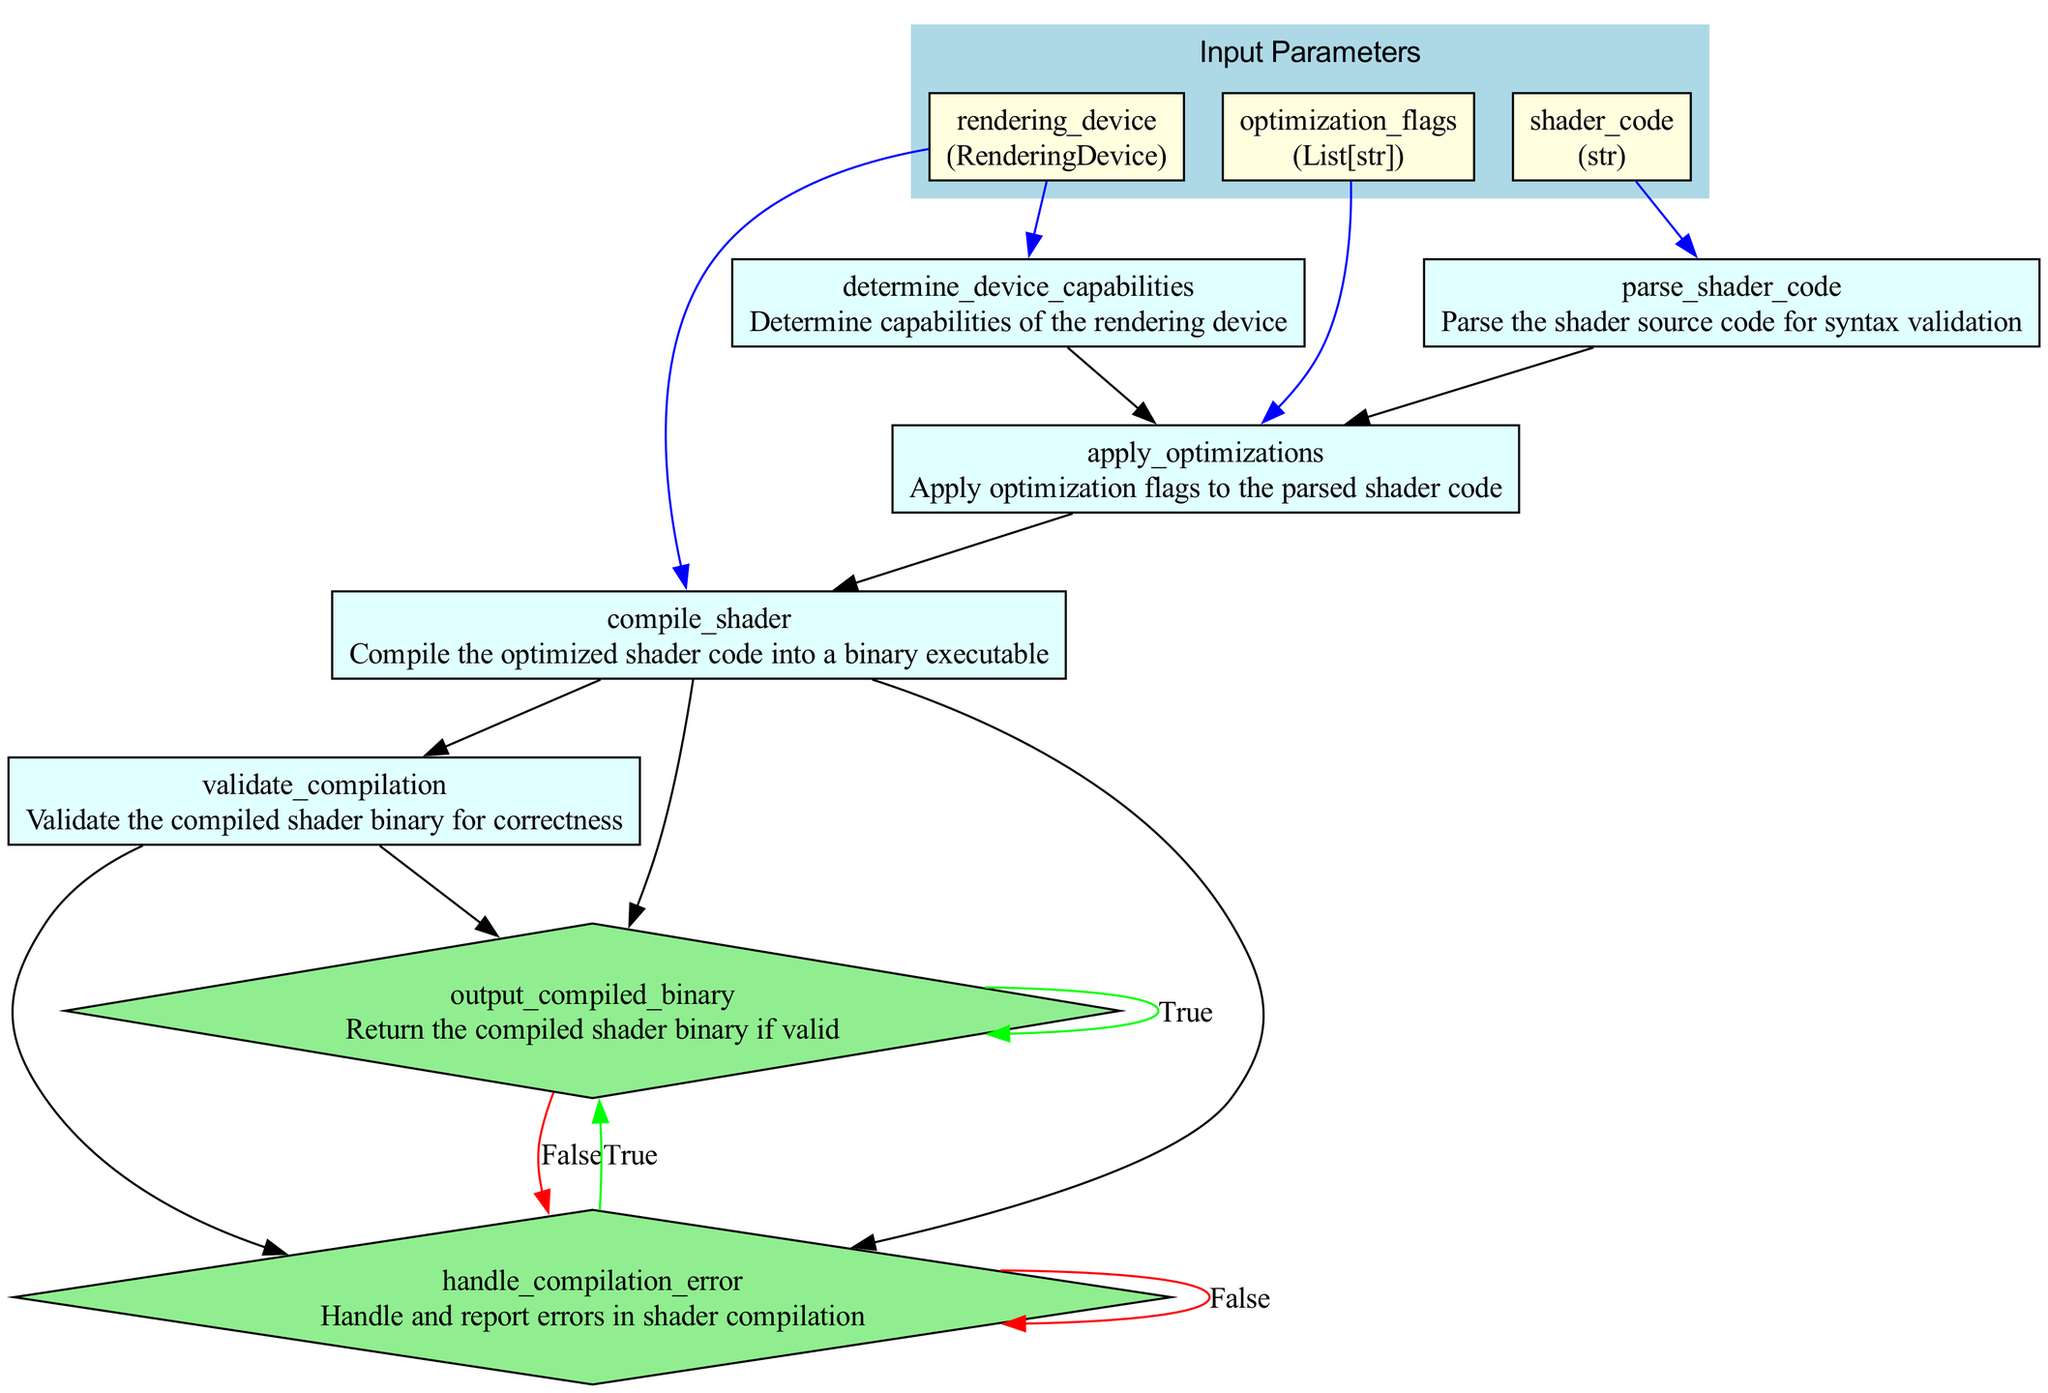What is the first step in the shader compilation optimization process? The first step listed in the flowchart is "parse_shader_code," which is responsible for parsing the shader source code for syntax validation.
Answer: parse_shader_code How many output nodes are present in this flowchart? By counting the output nodes listed in each step, there are seven corresponding outputs from the steps defined in the flowchart.
Answer: 7 What are the conditions for proceeding to the "output_compiled_binary" step? The "output_compiled_binary" step is reached only if the compiled binary is valid, as indicated by the condition "if is_valid."
Answer: if is_valid What is the second step that follows after determining device capabilities? After the step "determine_device_capabilities," the next step is "apply_optimizations," according to the flow of steps outlined in the diagram.
Answer: apply_optimizations Which step handles errors during shader compilation? The step that deals with errors is "handle_compilation_error," as it explicitly mentions handling and reporting errors in shader compilation.
Answer: handle_compilation_error What is produced after applying optimizations to the parsed shader code? The output that results after optimizations are applied is called "optimized_code," which is specifically noted in the output section of the "apply_optimizations" step.
Answer: optimized_code How many parameters are required for the function that optimizes shader compilation? The flowchart indicates a total of three parameters, which are "shader_code," "rendering_device," and "optimization_flags."
Answer: 3 In which step is the shader code compiled into a binary executable? The shader code is compiled in the "compile_shader" step, designed to produce a binary executable from the optimized shader code.
Answer: compile_shader What step follows after validating the compiled shader binary? Following the validation of the compiled shader binary, there are two potential steps depending on the validation outcome: "output_compiled_binary" or "handle_compilation_error."
Answer: output_compiled_binary or handle_compilation_error 